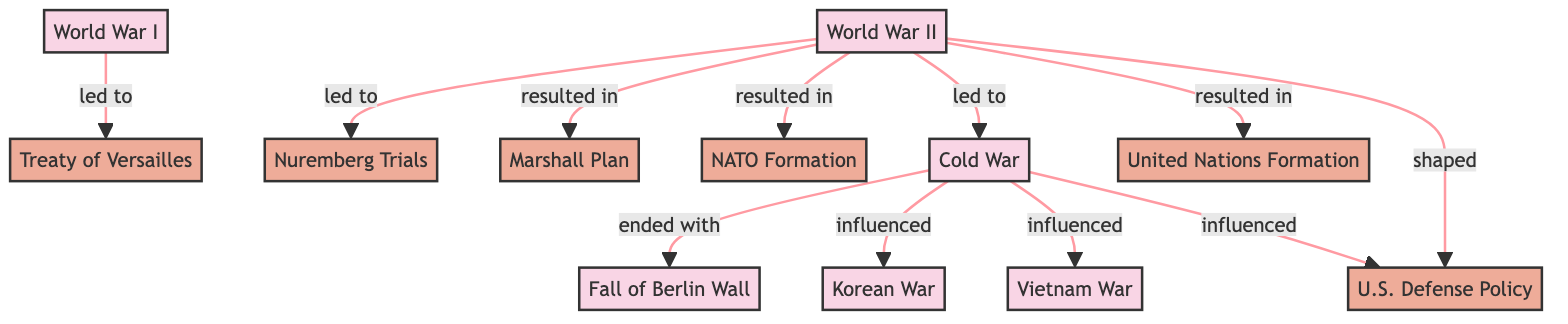What event led to the Treaty of Versailles? According to the diagram, the arrow indicates that World War I directly leads to the Treaty of Versailles, establishing a clear relationship.
Answer: World War I How many historical military events are represented in the diagram? By counting the nodes labeled as events, we find there are a total of six: World War I, World War II, Cold War, Korean War, Vietnam War, and Fall of Berlin Wall.
Answer: 6 What was shaped by World War II? The diagram shows an arrow from World War II pointing to U.S. Defense Policy, indicating that World War II influenced or shaped this policy area.
Answer: U.S. Defense Policy What event ended with the fall of the Berlin Wall? The diagram indicates that the Cold War is the event that concludes with the fall of the Berlin Wall, establishing a direct relationship between these two nodes.
Answer: Cold War Which policy resulted from World War II alongside NATO Formation? The diagram shows arrows from World War II to both the Marshall Plan and NATO Formation, meaning both were outcomes or results of World War II.
Answer: Marshall Plan Which two wars were influenced by the Cold War? Examining the connections from the Cold War, we see arrows pointing to both the Korean War and Vietnam War, indicating that both were influenced by Cold War dynamics.
Answer: Korean War and Vietnam War What do World War II and the United Nations Formation share? The diagram depicts that World War II resulted in the formation of the United Nations, establishing a direct connection between these two nodes.
Answer: United Nations Formation How many policies are depicted in the diagram? We can count the nodes categorized under policies in the diagram, which are Treaty of Versailles, Nuremberg Trials, Marshall Plan, NATO Formation, U.S. Defense Policy, and United Nations Formation, totaling six.
Answer: 6 What does the Korean War represent in the context of the Cold War? The diagram indicates that the Korean War is linked to the Cold War through an influence relationship, highlighting its context within the geopolitical climate of the time.
Answer: influenced 